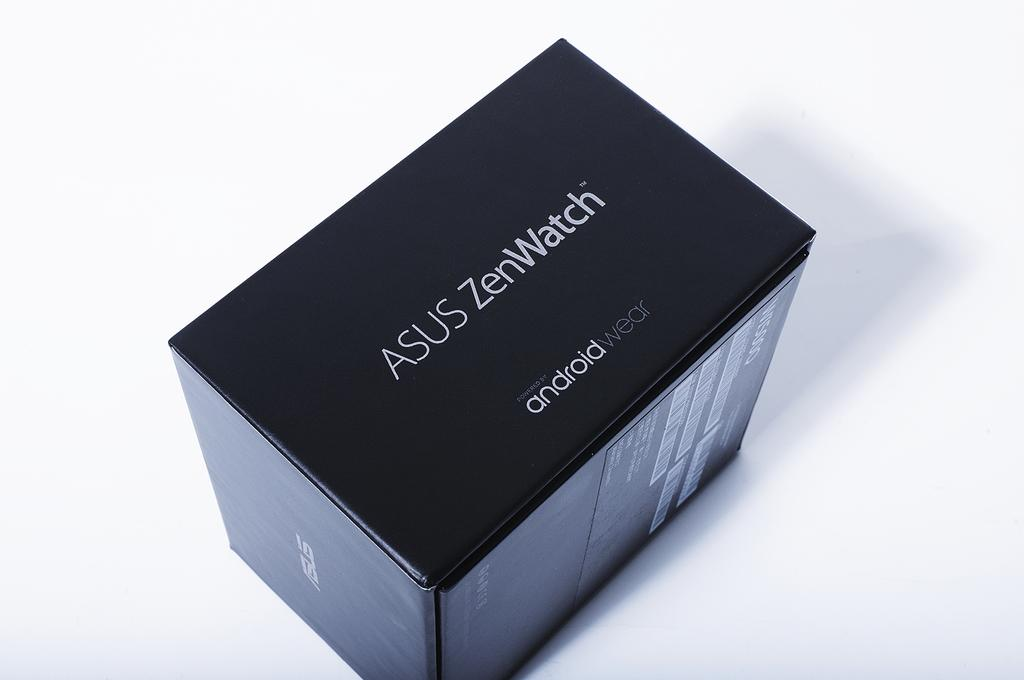Provide a one-sentence caption for the provided image. Smartwatch from Asus that is an android type product. 